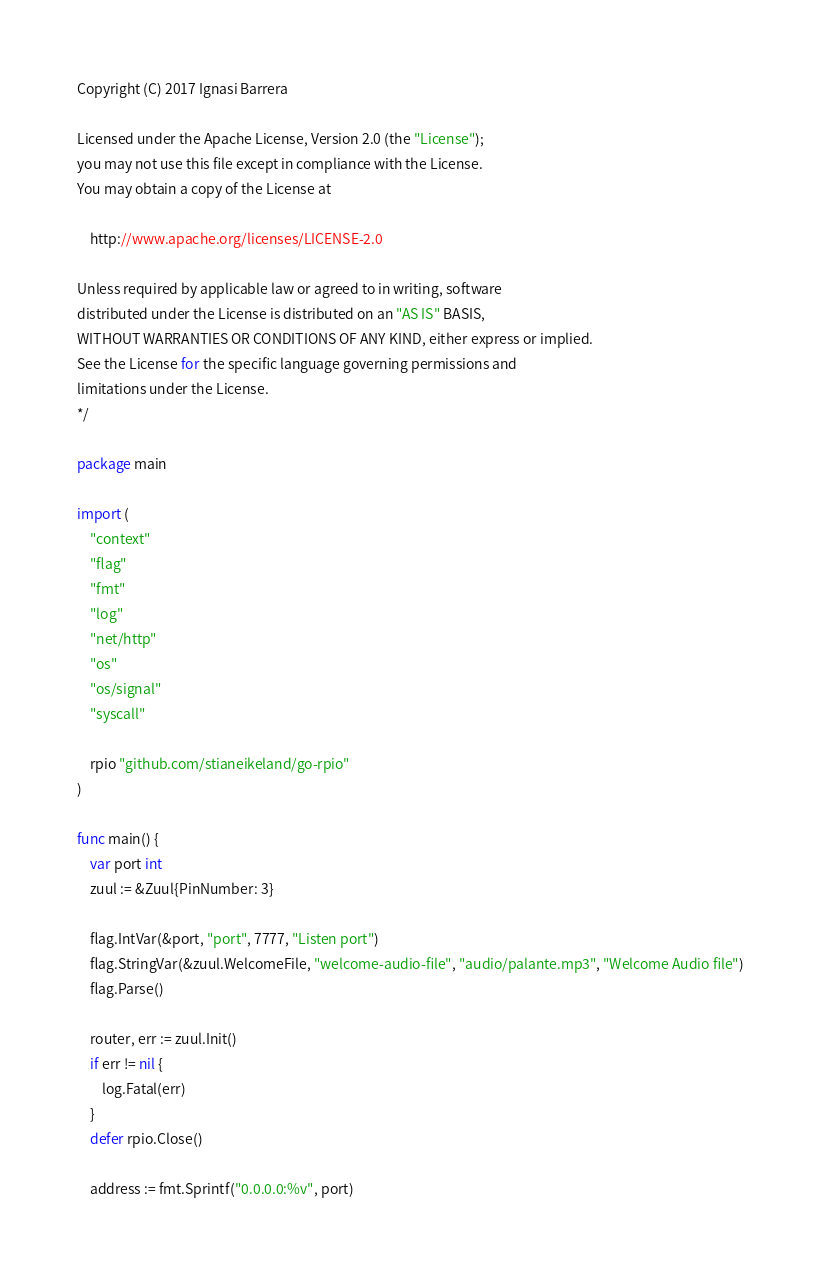<code> <loc_0><loc_0><loc_500><loc_500><_Go_>Copyright (C) 2017 Ignasi Barrera

Licensed under the Apache License, Version 2.0 (the "License");
you may not use this file except in compliance with the License.
You may obtain a copy of the License at

    http://www.apache.org/licenses/LICENSE-2.0

Unless required by applicable law or agreed to in writing, software
distributed under the License is distributed on an "AS IS" BASIS,
WITHOUT WARRANTIES OR CONDITIONS OF ANY KIND, either express or implied.
See the License for the specific language governing permissions and
limitations under the License.
*/

package main

import (
	"context"
	"flag"
	"fmt"
	"log"
	"net/http"
	"os"
	"os/signal"
	"syscall"

	rpio "github.com/stianeikeland/go-rpio"
)

func main() {
	var port int
	zuul := &Zuul{PinNumber: 3}

	flag.IntVar(&port, "port", 7777, "Listen port")
	flag.StringVar(&zuul.WelcomeFile, "welcome-audio-file", "audio/palante.mp3", "Welcome Audio file")
	flag.Parse()

	router, err := zuul.Init()
	if err != nil {
		log.Fatal(err)
	}
	defer rpio.Close()

	address := fmt.Sprintf("0.0.0.0:%v", port)</code> 